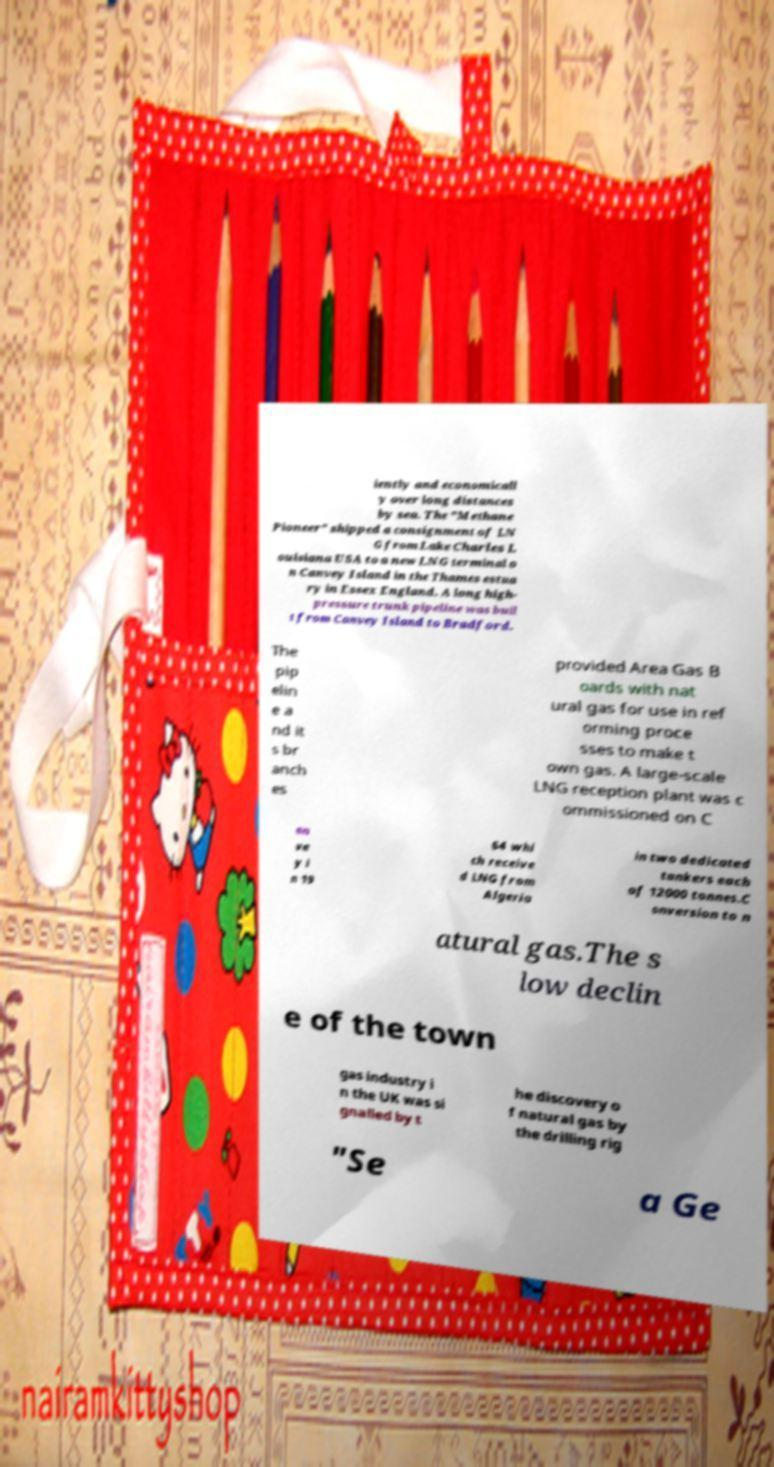I need the written content from this picture converted into text. Can you do that? iently and economicall y over long distances by sea. The "Methane Pioneer" shipped a consignment of LN G from Lake Charles L ouisiana USA to a new LNG terminal o n Canvey Island in the Thames estua ry in Essex England. A long high- pressure trunk pipeline was buil t from Canvey Island to Bradford. The pip elin e a nd it s br anch es provided Area Gas B oards with nat ural gas for use in ref orming proce sses to make t own gas. A large-scale LNG reception plant was c ommissioned on C an ve y i n 19 64 whi ch receive d LNG from Algeria in two dedicated tankers each of 12000 tonnes.C onversion to n atural gas.The s low declin e of the town gas industry i n the UK was si gnalled by t he discovery o f natural gas by the drilling rig "Se a Ge 